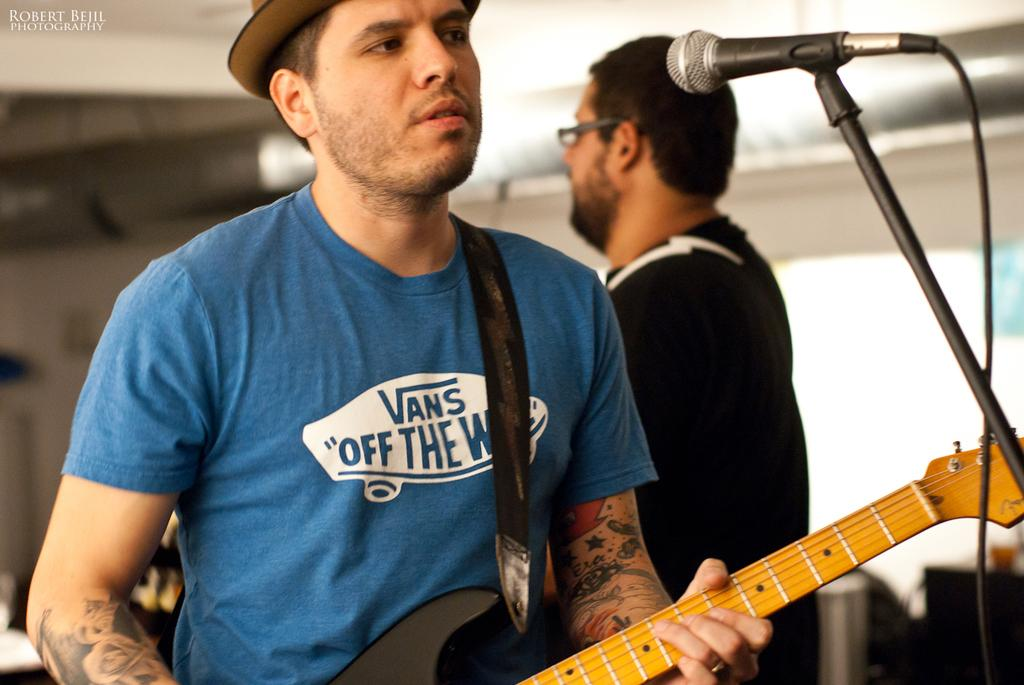How many people are in the image? There are two people in the image. What is the man doing in the image? The man is sitting and holding a guitar. What object is present in the image that is commonly used for amplifying sound? There is a microphone in the image. What type of guide is the man holding in the image? There is no guide present in the image; the man is holding a guitar. Can you tell me how many buttons are on the airplane in the image? There is no airplane present in the image, so it is not possible to determine the number of buttons on an airplane. 